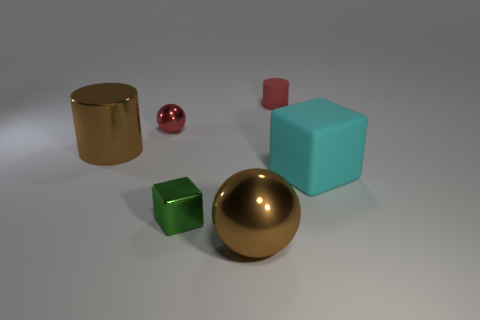How many matte cylinders have the same color as the small sphere?
Give a very brief answer. 1. There is a brown object behind the rubber object that is on the right side of the red object right of the large brown metallic ball; what shape is it?
Offer a terse response. Cylinder. What is the big brown cylinder made of?
Offer a very short reply. Metal. There is a large cube that is the same material as the tiny red cylinder; what is its color?
Ensure brevity in your answer.  Cyan. Are there any metal cubes right of the brown ball right of the green block?
Keep it short and to the point. No. How many other things are there of the same shape as the red metallic thing?
Offer a terse response. 1. Does the small red thing to the left of the brown sphere have the same shape as the metallic object that is left of the red ball?
Offer a terse response. No. What number of big metal things are behind the tiny red object that is to the left of the tiny object that is to the right of the big brown ball?
Keep it short and to the point. 0. What is the color of the big matte block?
Provide a succinct answer. Cyan. There is another object that is the same shape as the small green thing; what is it made of?
Give a very brief answer. Rubber. 